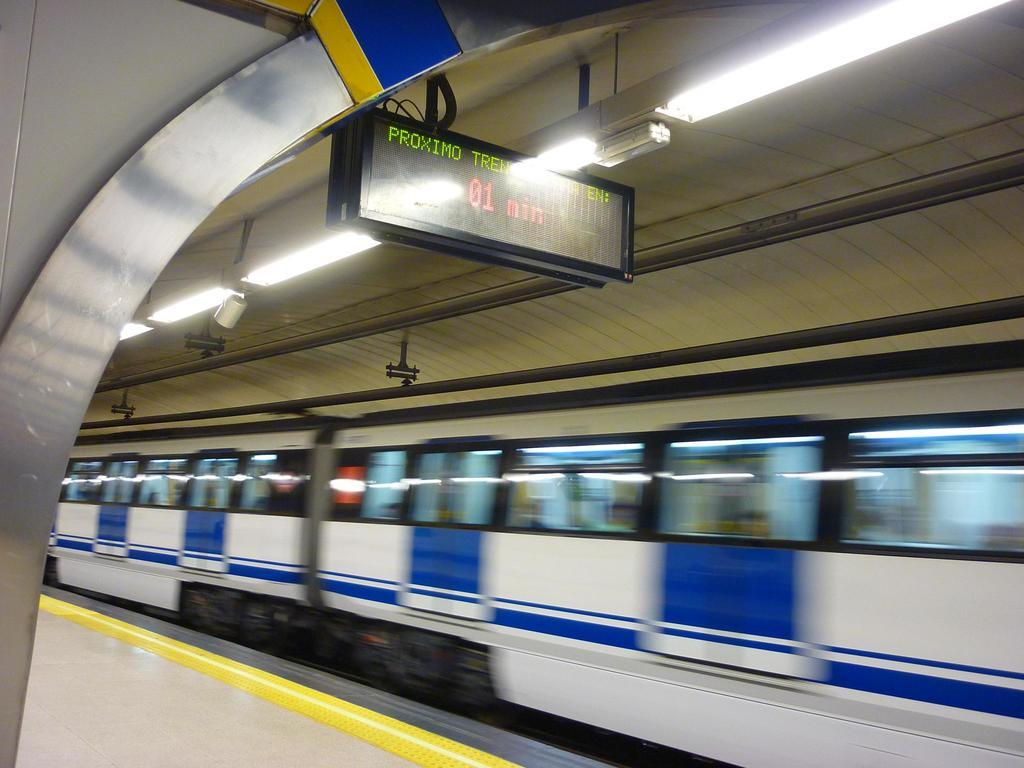What is the main subject in the center of the image? There is a train in the center of the image. What can be seen above the train in the image? There is a ceiling at the top of the image. What type of illumination is present in the image? There are lights visible in the image. What is located at the bottom of the image? There is a platform at the bottom of the image. What is the income of the foot visible in the image? There is no foot present in the image, so it is not possible to determine its income. 